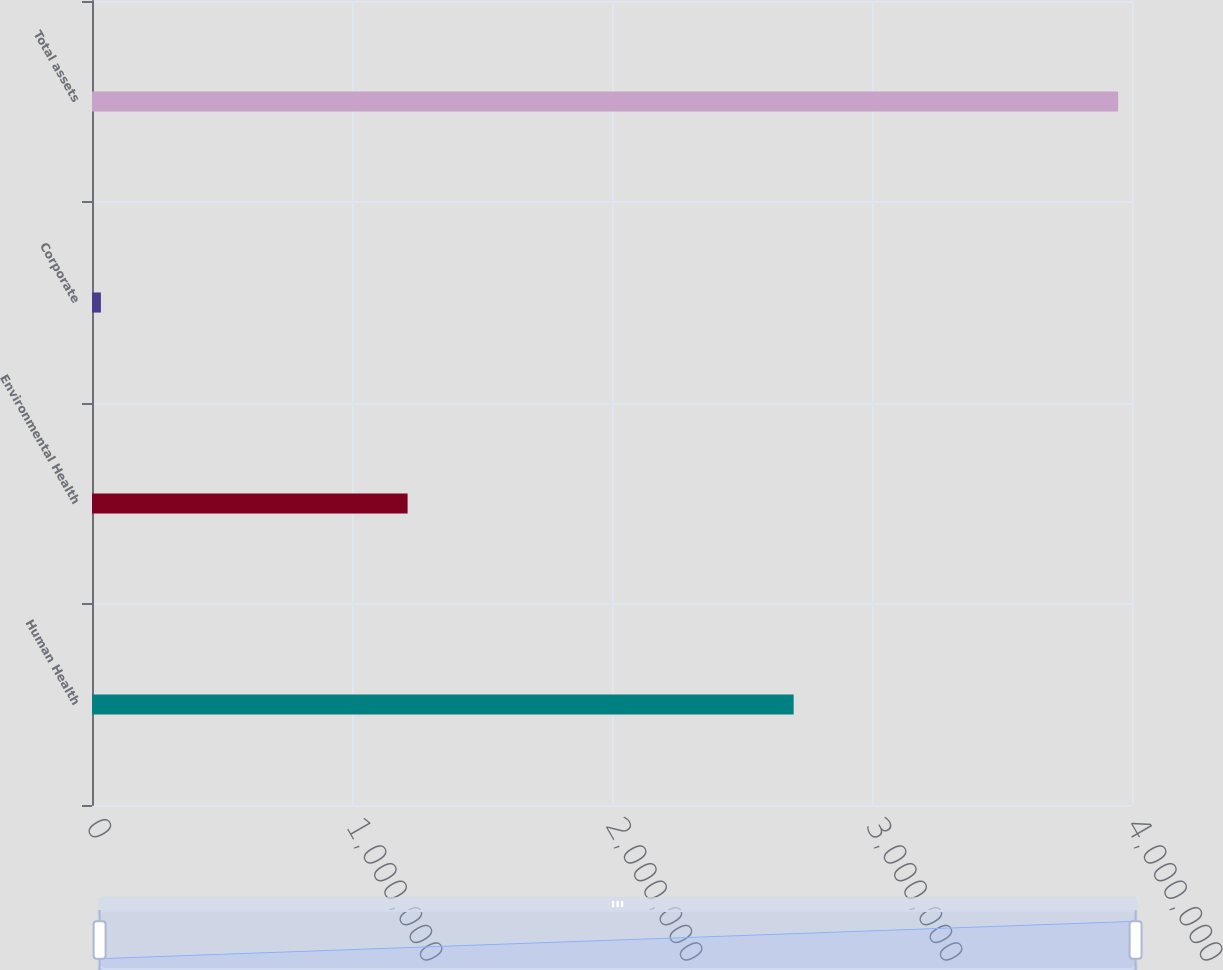Convert chart. <chart><loc_0><loc_0><loc_500><loc_500><bar_chart><fcel>Human Health<fcel>Environmental Health<fcel>Corporate<fcel>Total assets<nl><fcel>2.69864e+06<fcel>1.2138e+06<fcel>34271<fcel>3.94671e+06<nl></chart> 